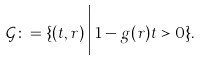<formula> <loc_0><loc_0><loc_500><loc_500>\mathcal { G } \colon = \{ ( t , r ) \, \Big | \, 1 - g ( r ) t > 0 \} .</formula> 